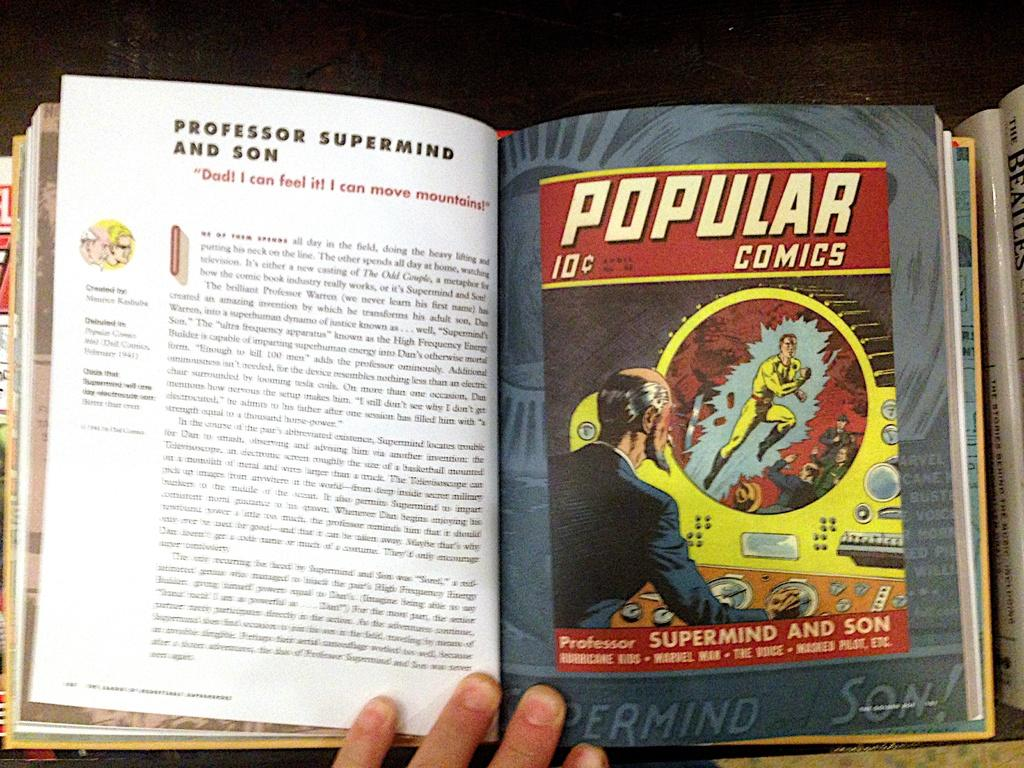What object is present in the image? There is a book in the image. What can be found within the book? The book contains depictions of persons and text. Can you describe the fingers visible at the bottom of the image? The fingers are likely holding or touching the book. How many trees are visible in the image? There are no trees visible in the image; it features a book with fingers at the bottom. Can you describe the chess game being played in the image? There is no chess game present in the image; it only contains a book and fingers. 